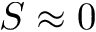<formula> <loc_0><loc_0><loc_500><loc_500>S \approx 0</formula> 